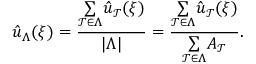Convert formula to latex. <formula><loc_0><loc_0><loc_500><loc_500>\hat { u } _ { \Lambda } ( \xi ) = \frac { \underset { \mathcal { T } \in \Lambda } { \sum } \hat { u } _ { \mathcal { T } } ( \xi ) } { | \Lambda | } = \frac { \underset { \mathcal { T } \in \Lambda } { \sum } \hat { u } _ { \mathcal { T } } ( \xi ) } { \underset { \mathcal { T } \in \Lambda } { \sum } A _ { \mathcal { T } } } .</formula> 